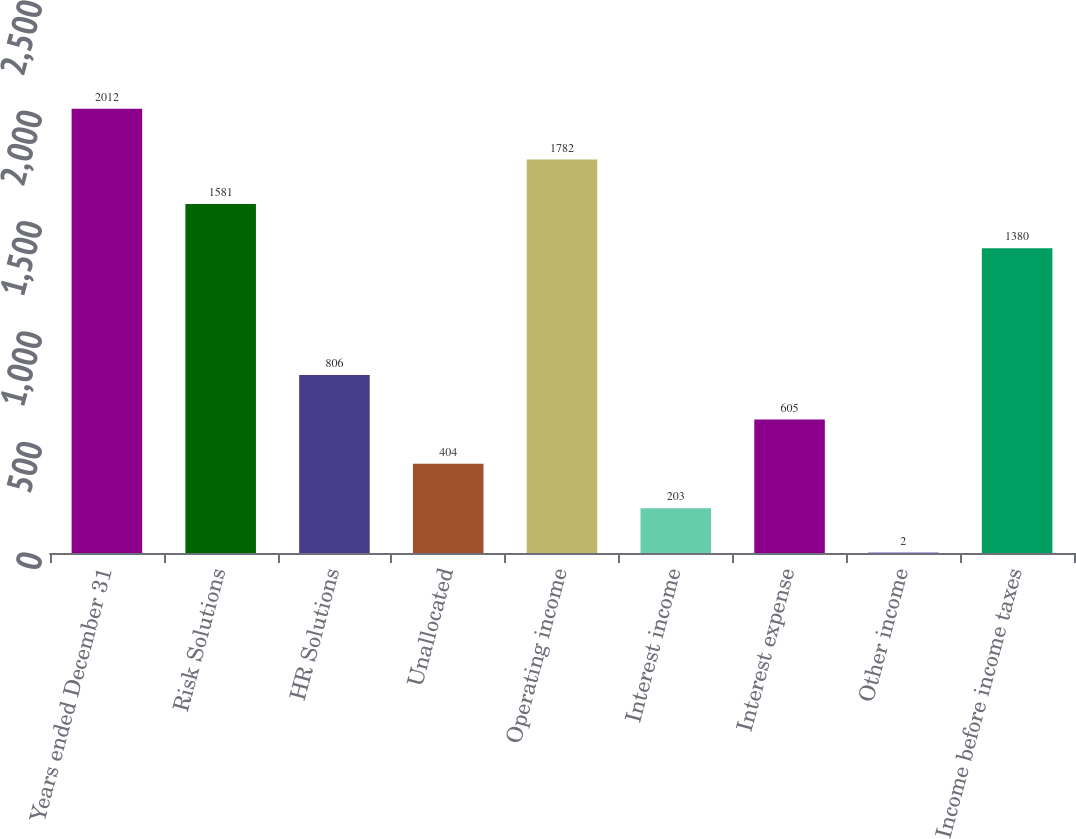Convert chart. <chart><loc_0><loc_0><loc_500><loc_500><bar_chart><fcel>Years ended December 31<fcel>Risk Solutions<fcel>HR Solutions<fcel>Unallocated<fcel>Operating income<fcel>Interest income<fcel>Interest expense<fcel>Other income<fcel>Income before income taxes<nl><fcel>2012<fcel>1581<fcel>806<fcel>404<fcel>1782<fcel>203<fcel>605<fcel>2<fcel>1380<nl></chart> 